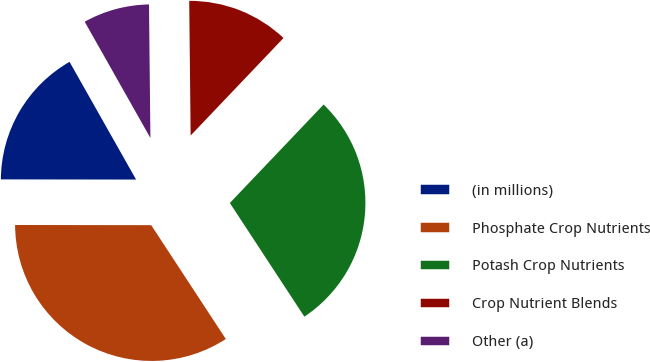<chart> <loc_0><loc_0><loc_500><loc_500><pie_chart><fcel>(in millions)<fcel>Phosphate Crop Nutrients<fcel>Potash Crop Nutrients<fcel>Crop Nutrient Blends<fcel>Other (a)<nl><fcel>16.79%<fcel>34.25%<fcel>28.65%<fcel>12.28%<fcel>8.02%<nl></chart> 